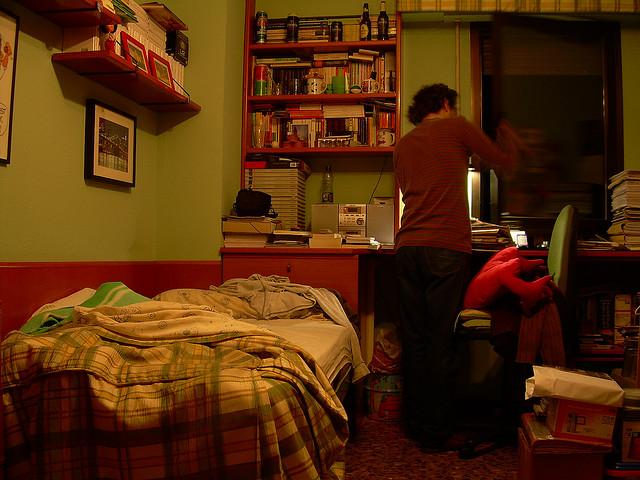What is in the room? bed 